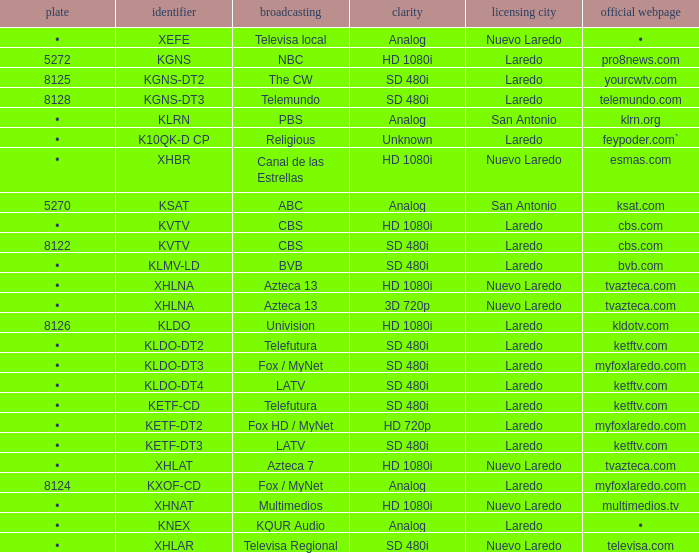Name the resolution with dish of 8126 HD 1080i. 